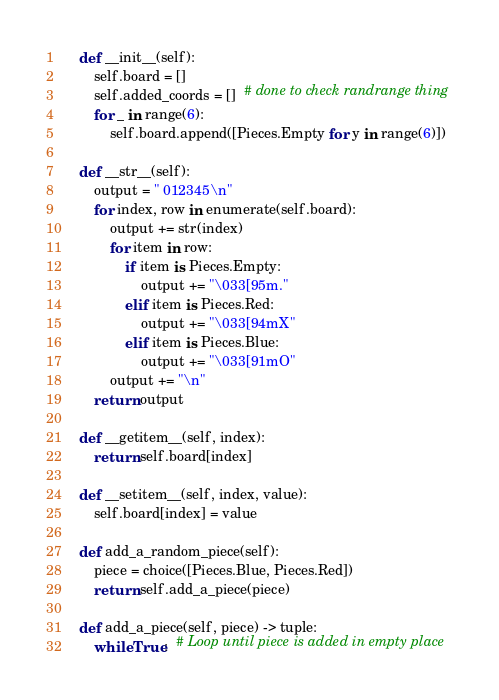Convert code to text. <code><loc_0><loc_0><loc_500><loc_500><_Python_>
    def __init__(self):
        self.board = []
        self.added_coords = []  # done to check randrange thing
        for _ in range(6):
            self.board.append([Pieces.Empty for y in range(6)])

    def __str__(self):
        output = " 012345\n"
        for index, row in enumerate(self.board):
            output += str(index)
            for item in row:
                if item is Pieces.Empty:
                    output += "\033[95m."
                elif item is Pieces.Red:
                    output += "\033[94mX"
                elif item is Pieces.Blue:
                    output += "\033[91mO"
            output += "\n"
        return output

    def __getitem__(self, index):
        return self.board[index]

    def __setitem__(self, index, value):
        self.board[index] = value

    def add_a_random_piece(self):
        piece = choice([Pieces.Blue, Pieces.Red])
        return self.add_a_piece(piece)

    def add_a_piece(self, piece) -> tuple:
        while True:  # Loop until piece is added in empty place</code> 